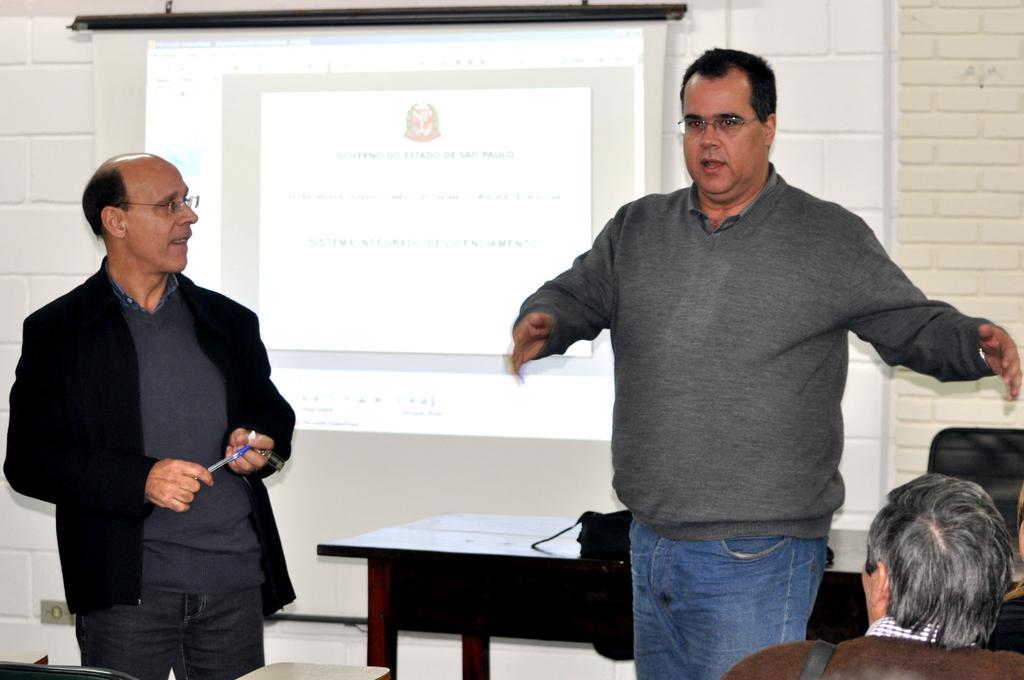Please provide a concise description of this image. This is a presentation, we can see two people standing over here , one person wearing black color blazer and holding a pen in his hand and looking at another person who is standing beside him, this person is wearing a grey color shirt and spectacles and explaining about the presentation. There is a table behind them and also a black color bag on the table. In the background there is a white color wall with white color tiles and also a tab sorry chair which is black color. 